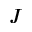<formula> <loc_0><loc_0><loc_500><loc_500>J</formula> 